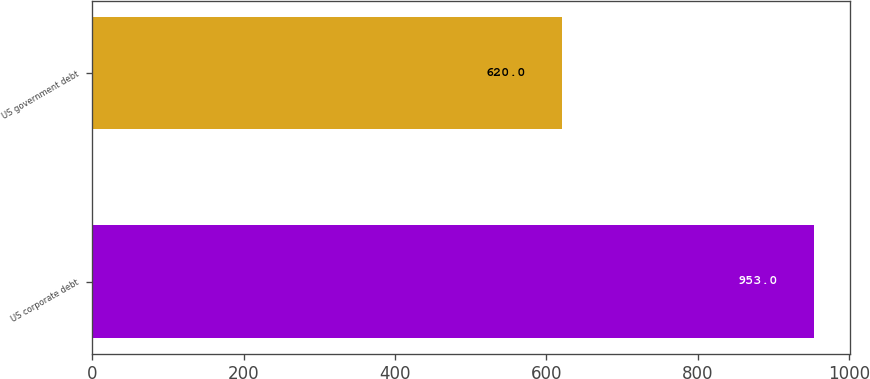Convert chart to OTSL. <chart><loc_0><loc_0><loc_500><loc_500><bar_chart><fcel>US corporate debt<fcel>US government debt<nl><fcel>953<fcel>620<nl></chart> 